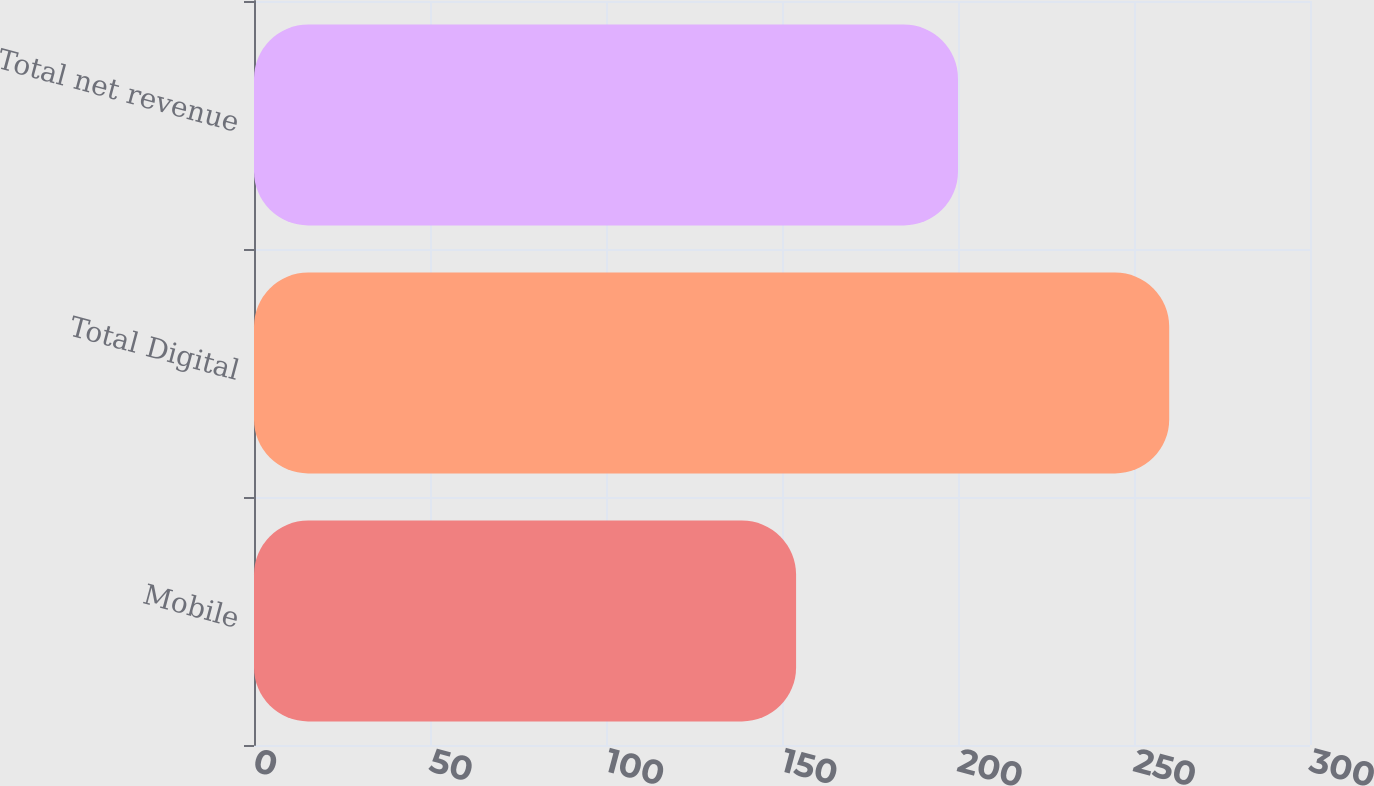Convert chart to OTSL. <chart><loc_0><loc_0><loc_500><loc_500><bar_chart><fcel>Mobile<fcel>Total Digital<fcel>Total net revenue<nl><fcel>154<fcel>260<fcel>200<nl></chart> 